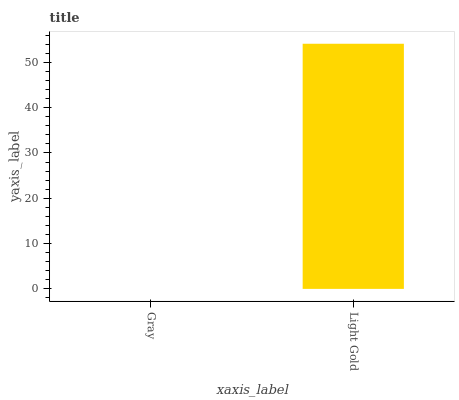Is Gray the minimum?
Answer yes or no. Yes. Is Light Gold the maximum?
Answer yes or no. Yes. Is Light Gold the minimum?
Answer yes or no. No. Is Light Gold greater than Gray?
Answer yes or no. Yes. Is Gray less than Light Gold?
Answer yes or no. Yes. Is Gray greater than Light Gold?
Answer yes or no. No. Is Light Gold less than Gray?
Answer yes or no. No. Is Light Gold the high median?
Answer yes or no. Yes. Is Gray the low median?
Answer yes or no. Yes. Is Gray the high median?
Answer yes or no. No. Is Light Gold the low median?
Answer yes or no. No. 